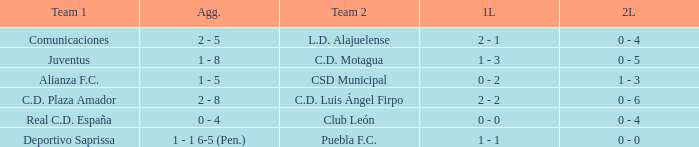What is the 2nd leg of the Comunicaciones team? 0 - 4. 